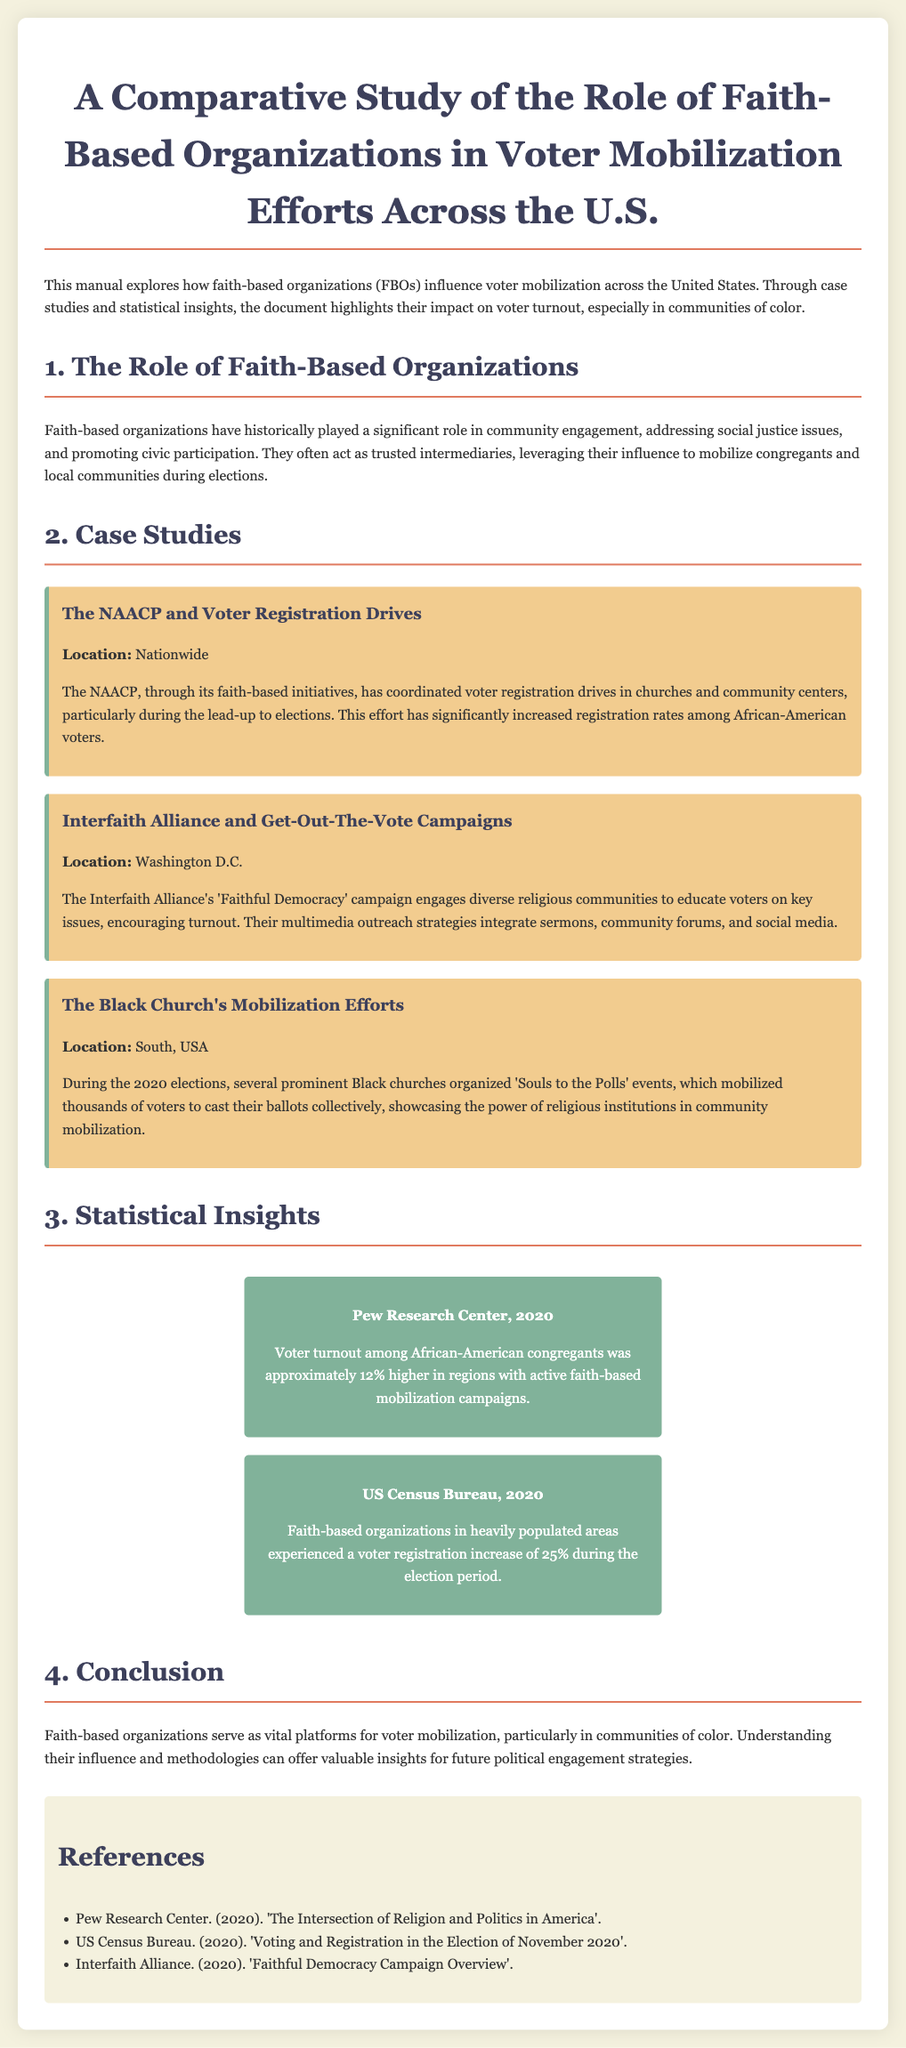what is the title of the manual? The title is stated at the beginning of the document.
Answer: A Comparative Study of the Role of Faith-Based Organizations in Voter Mobilization Efforts Across the U.S who coordinated voter registration drives nationwide? The organization mentioned for coordinating these drives is highlighted in the case studies section.
Answer: NAACP what campaign did the Interfaith Alliance initiate? This information is found in the case study regarding their efforts.
Answer: Faithful Democracy what was the percentage increase in voter turnout among African-American congregants according to Pew Research Center? This statistic is found in the statistical insights section.
Answer: 12% in which region did the Black church mobilize voters collectively? The location is specified in the case studies section of the document.
Answer: South, USA what was the increase in voter registration during the election period in heavily populated areas? This statistic is mentioned in the statistical insights section.
Answer: 25% what year does the US Census Bureau statistic refer to? The year is indicated in the statistics section.
Answer: 2020 what is one primary role of faith-based organizations in the document? This is summarized in the introduction of the manual.
Answer: Mobilize congregants who published the report cited in the references regarding religion and politics? The publisher of the report is mentioned in the references section.
Answer: Pew Research Center 